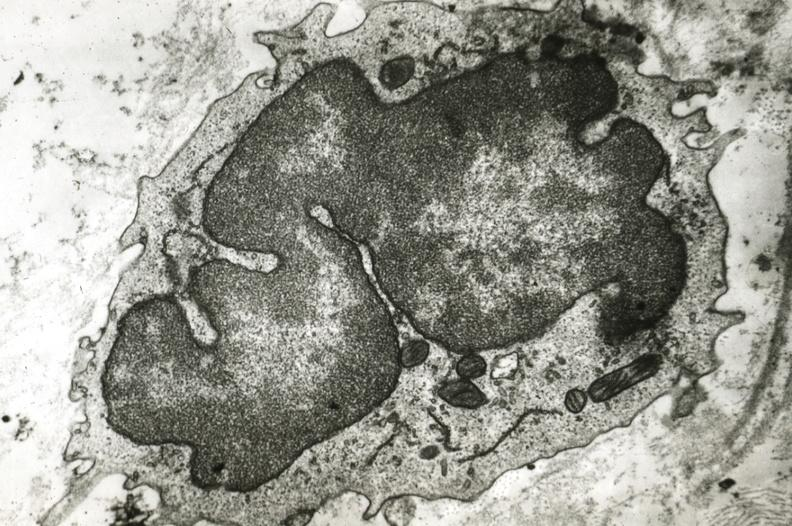what is present?
Answer the question using a single word or phrase. Coronary artery 